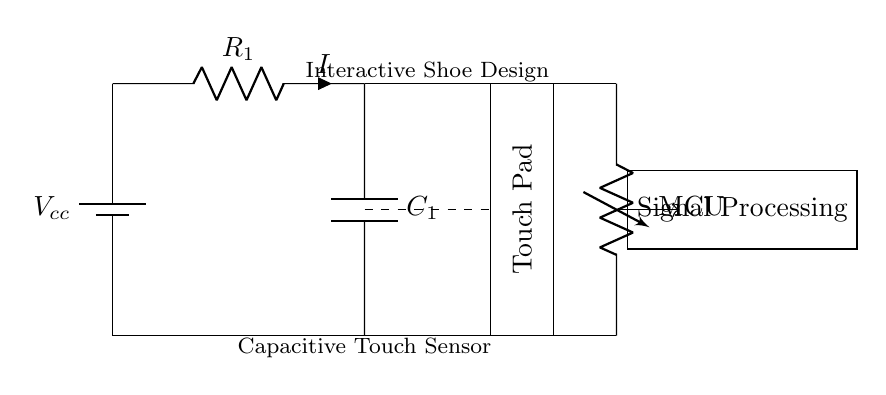What is the type of the voltage source in this circuit? The circuit contains a battery, which is classified as a voltage source providing the necessary supply voltage for operation.
Answer: Battery What component is labeled R1 in the circuit? R1 represents a resistor that limits the current flowing through the circuit, essential for maintaining proper operation of the capacitive touch sensor and avoiding damage to components.
Answer: Resistor How many main components are there in the circuit shown? When counting the main components, we observe a battery, a resistor, a capacitor, and a microcontroller; thus, there are four main components involved in the design.
Answer: Four What type of sensor is represented in this circuit? The circuit design features a capacitive touch sensor, which detects capacitance changes linked to touch or proximity, enabling interactivity in the shoe design.
Answer: Capacitive touch sensor What does the dashed line in the circuit signify? Dashed lines typically indicate a non-electrical connection or a conceptual link; in this case, it separates the touch pad from the rest of the components while indicating an interactive element.
Answer: Conceptual connection What role does the capacitor play in this circuit? The capacitor (C1) stores electrical energy temporarily, enabling it to smooth out fluctuations in the touch signal, thus enhancing the sensitivity and reliability of the touch sensor's operation.
Answer: Energy storage How does the touch pad interact with the circuit? The touch pad, when activated by a user's touch, changes the capacitance at that point, which is then read by the microcontroller (MCU) to produce a corresponding output signal or action.
Answer: Changes capacitance 